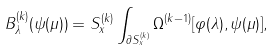Convert formula to latex. <formula><loc_0><loc_0><loc_500><loc_500>B _ { \lambda } ^ { ( k ) } ( \psi ( \mu ) ) = S _ { x } ^ { ( k ) } \int _ { \partial S _ { x } ^ { ( k ) } } \Omega ^ { ( k - 1 ) } [ \varphi ( \lambda ) , \psi ( \mu ) ] ,</formula> 